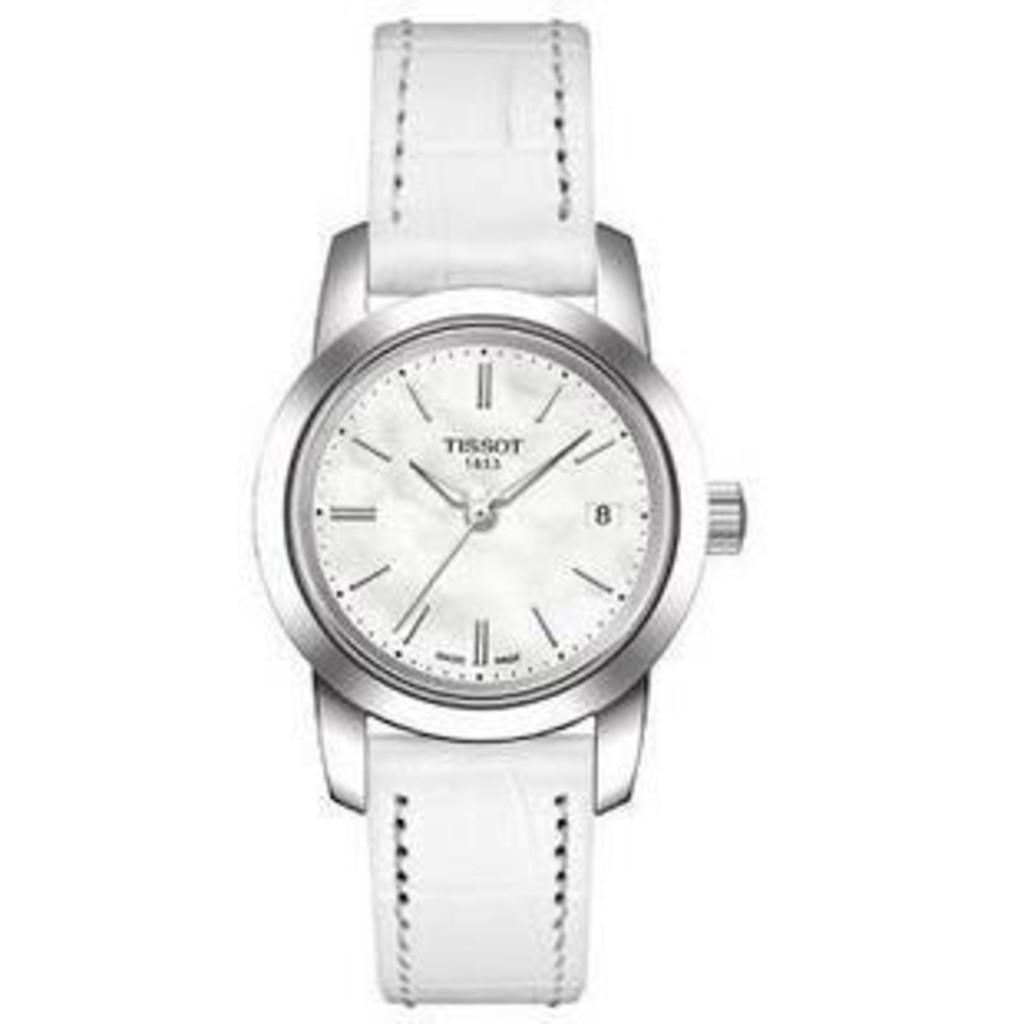<image>
Create a compact narrative representing the image presented. A white Tissot watch is displayed against a white background. 